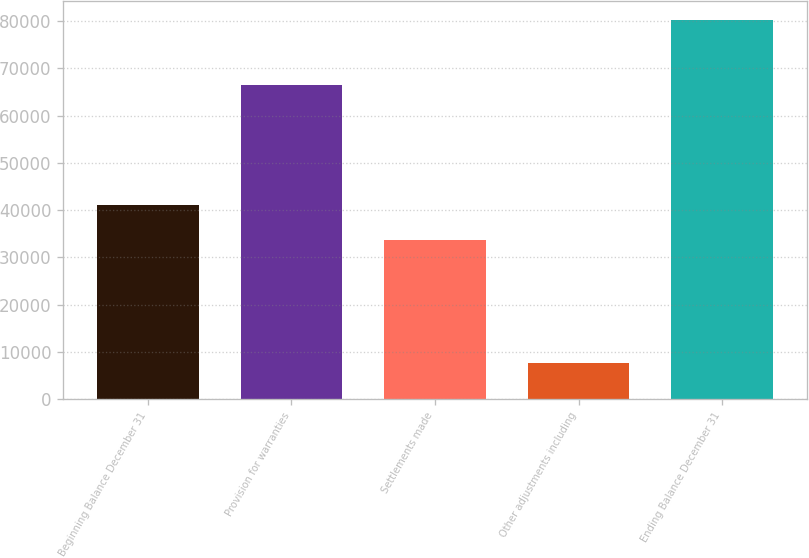Convert chart to OTSL. <chart><loc_0><loc_0><loc_500><loc_500><bar_chart><fcel>Beginning Balance December 31<fcel>Provision for warranties<fcel>Settlements made<fcel>Other adjustments including<fcel>Ending Balance December 31<nl><fcel>41033.4<fcel>66457<fcel>33759<fcel>7587<fcel>80331<nl></chart> 